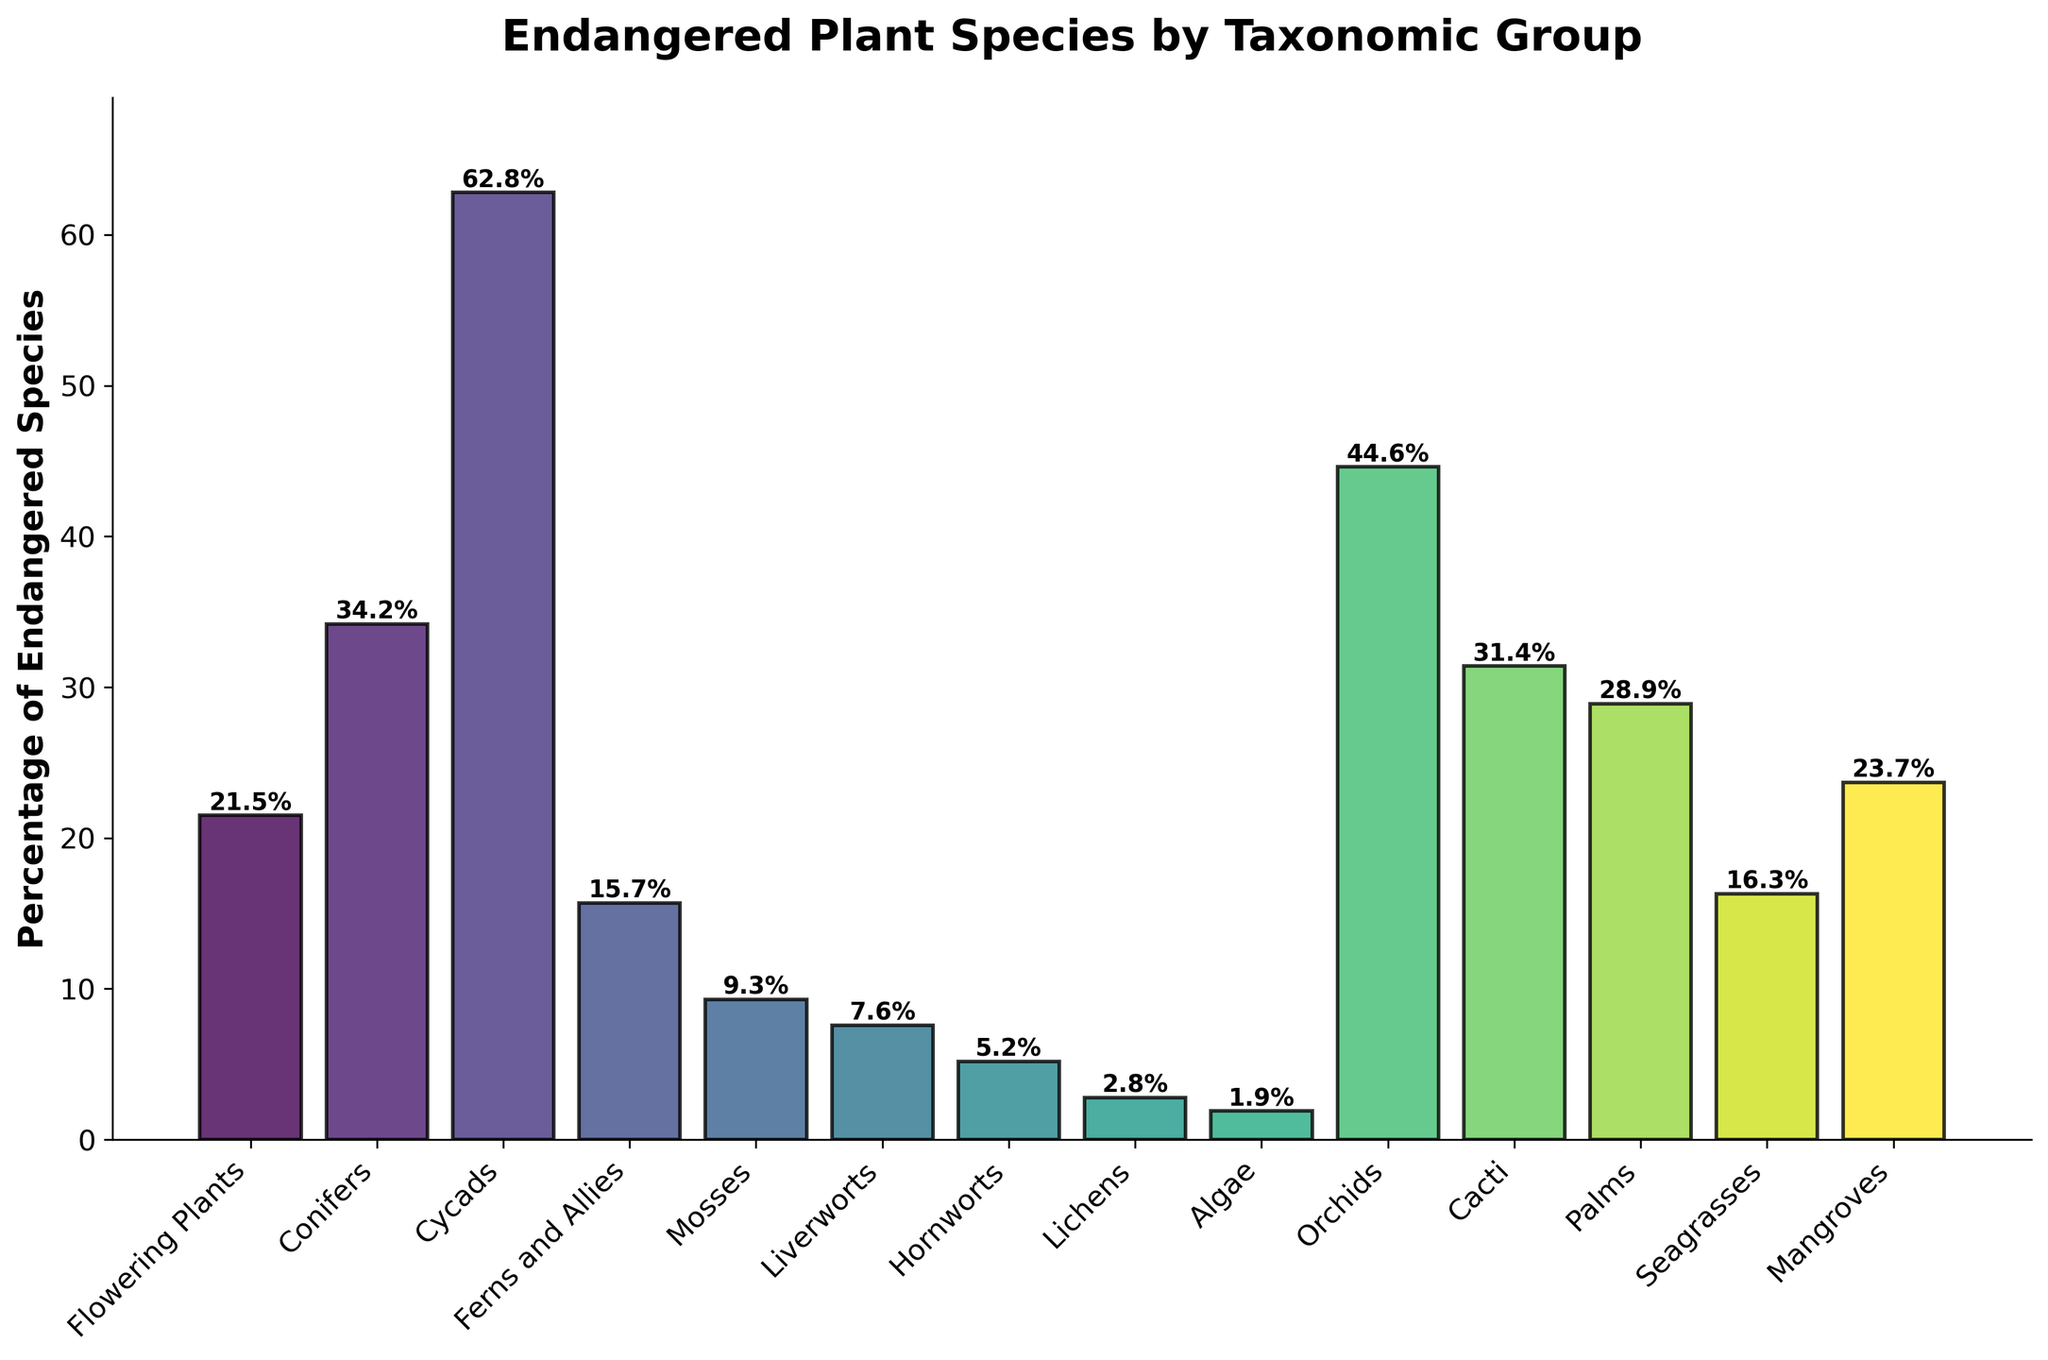What taxonomic group has the highest percentage of endangered species? By examining the height of the bars and their corresponding labels, the bar representing Cycads is the tallest, indicating the highest percentage.
Answer: Cycads Which two taxonomic groups have a percentage of endangered species above 40%? The bars representing Orchids and Cycads are above 40%, as visually confirmed by their heights and labeled values of 44.6% and 62.8%, respectively.
Answer: Orchids and Cycads What is the difference in the percentage of endangered species between Orchids and Liverworts? The percentage of endangered species in Orchids is 44.6% and in Liverworts is 7.6%. The difference is 44.6% - 7.6% = 37%.
Answer: 37% How many taxonomic groups have less than 10% of their species endangered? By counting the bars with heights below the 10% mark, and checking their labeled values, these taxonomic groups are Mosses (9.3%), Liverworts (7.6%), Hornworts (5.2%), Lichens (2.8%), and Algae (1.9%) – a total of 5 groups.
Answer: 5 Which taxonomic group shows a percentage of endangered species closest to 25%? Looking at the bars around 25%, Mangroves have a percentage of 23.7%, which is visually closest to 25%.
Answer: Mangroves What is the combined percentage of endangered species for the taxonomic groups with the lowest and highest values? The lowest percentage is for Algae at 1.9% and the highest is for Cycads at 62.8%. Adding these values gives 1.9% + 62.8% = 64.7%.
Answer: 64.7% Is the percentage of endangered species in Cacti greater than that in Palms? By comparing the height of the two bars, Cacti (31.4%) and Palms (28.9%), it's evident that the Cacti bar is taller.
Answer: Yes How does the percentage of endangered species in Flowering Plants compare to that in Mangroves? The bar for Flowering Plants shows 21.5% and for Mangroves shows 23.7%. Mangroves have a slightly higher percentage.
Answer: Mangroves Which taxa has more endangered species, Ferns and Allies or Seagrasses? What is the difference? The percentage for Ferns and Allies is 15.7%, and for Seagrasses, it is 16.3%. Seagrasses have a slightly higher percentage. The difference is 16.3% - 15.7% = 0.6%.
Answer: Seagrasses, 0.6% 